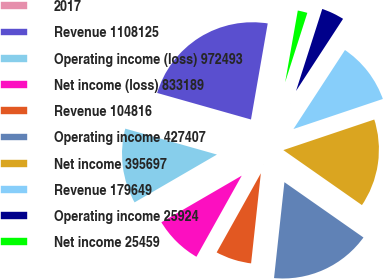Convert chart. <chart><loc_0><loc_0><loc_500><loc_500><pie_chart><fcel>2017<fcel>Revenue 1108125<fcel>Operating income (loss) 972493<fcel>Net income (loss) 833189<fcel>Revenue 104816<fcel>Operating income 427407<fcel>Net income 395697<fcel>Revenue 179649<fcel>Operating income 25924<fcel>Net income 25459<nl><fcel>0.03%<fcel>23.36%<fcel>12.76%<fcel>8.52%<fcel>6.39%<fcel>17.0%<fcel>14.88%<fcel>10.64%<fcel>4.27%<fcel>2.15%<nl></chart> 